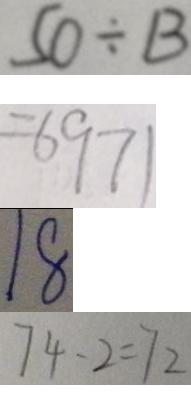<formula> <loc_0><loc_0><loc_500><loc_500>5 3 \div B 
 = 6 9 7 1 
 1 8 
 7 4 - 2 = 7 2</formula> 